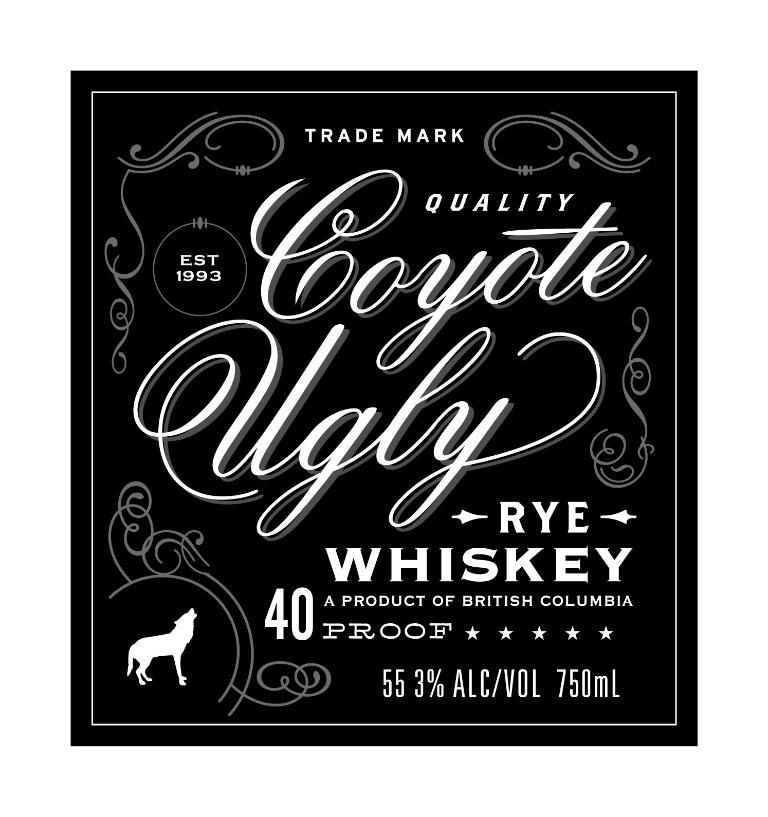Provide a one-sentence caption for the provided image. The label from a bottle of Coyote Ugly Rye whiskey which is 40 proof and comes from British Columbia. 